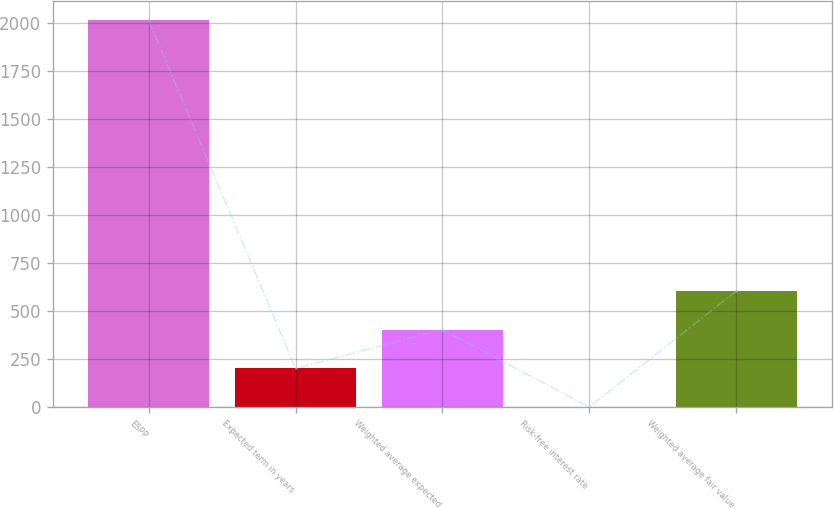Convert chart to OTSL. <chart><loc_0><loc_0><loc_500><loc_500><bar_chart><fcel>ESPP<fcel>Expected term in years<fcel>Weighted average expected<fcel>Risk-free interest rate<fcel>Weighted average fair value<nl><fcel>2014<fcel>201.47<fcel>402.86<fcel>0.08<fcel>604.25<nl></chart> 